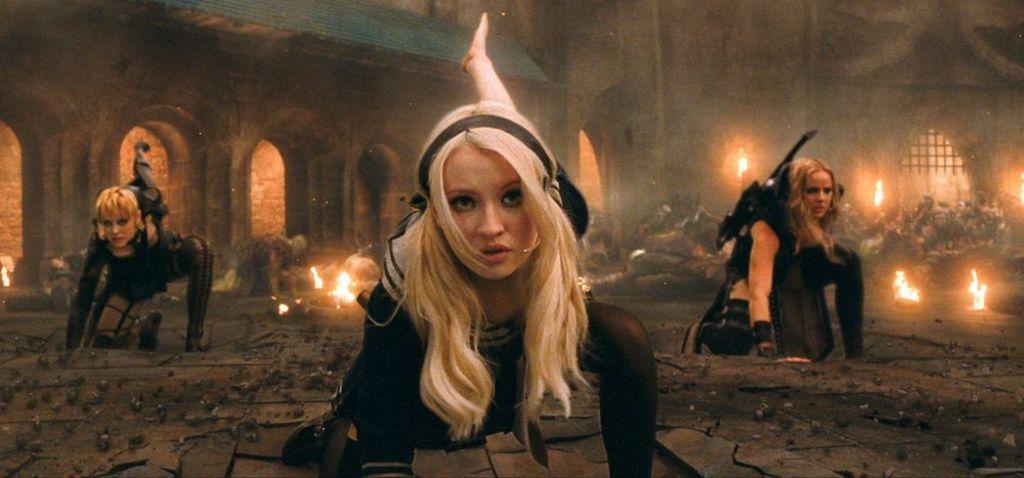Describe this image in one or two sentences. In this image there are three women kneeling on the ground. Behind them there are many people on the ground. There is fire in the image. In the background there are buildings. 